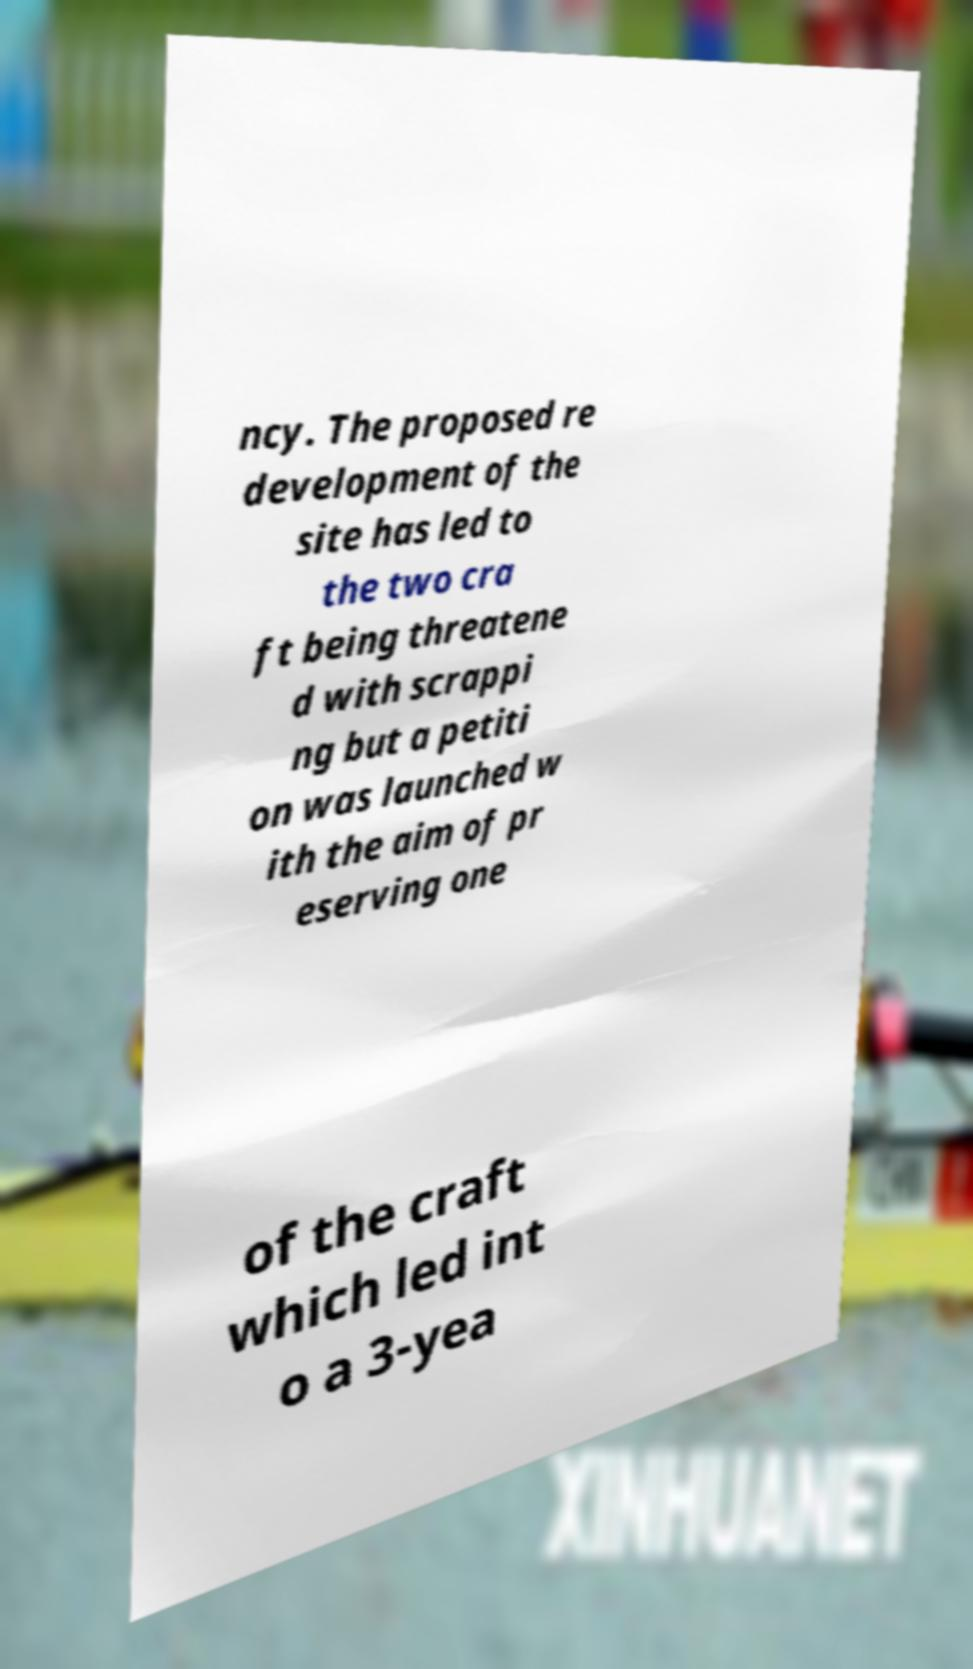Could you assist in decoding the text presented in this image and type it out clearly? ncy. The proposed re development of the site has led to the two cra ft being threatene d with scrappi ng but a petiti on was launched w ith the aim of pr eserving one of the craft which led int o a 3-yea 